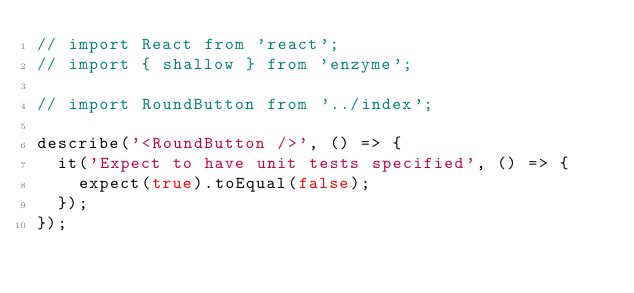<code> <loc_0><loc_0><loc_500><loc_500><_JavaScript_>// import React from 'react';
// import { shallow } from 'enzyme';

// import RoundButton from '../index';

describe('<RoundButton />', () => {
  it('Expect to have unit tests specified', () => {
    expect(true).toEqual(false);
  });
});
</code> 